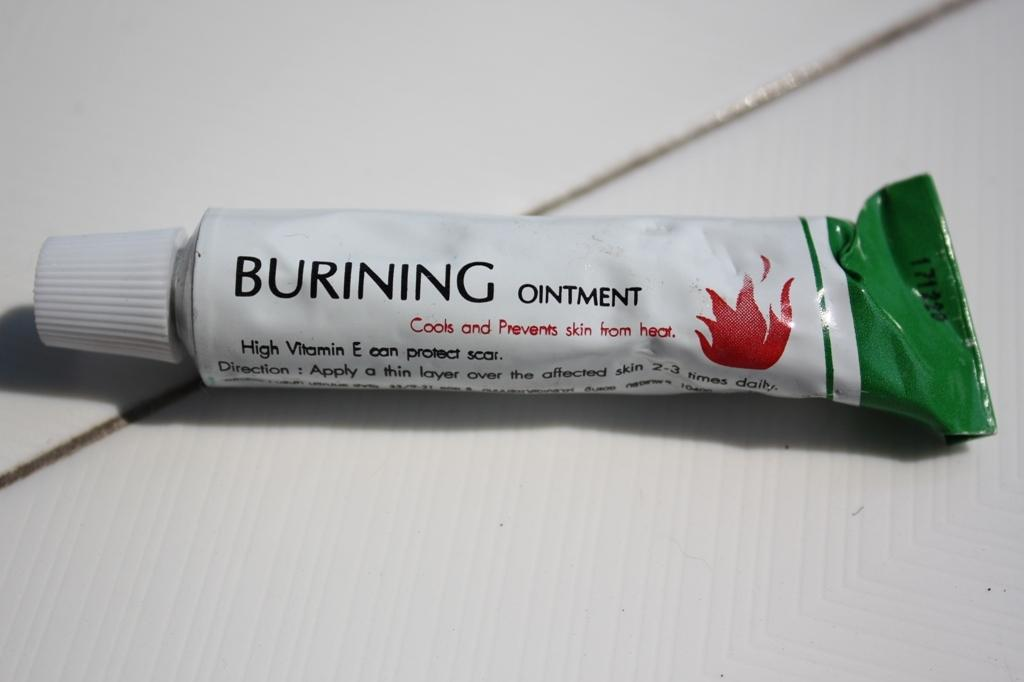<image>
Render a clear and concise summary of the photo. A tube of ointment to put on the skin, that contains Vitamim E. 